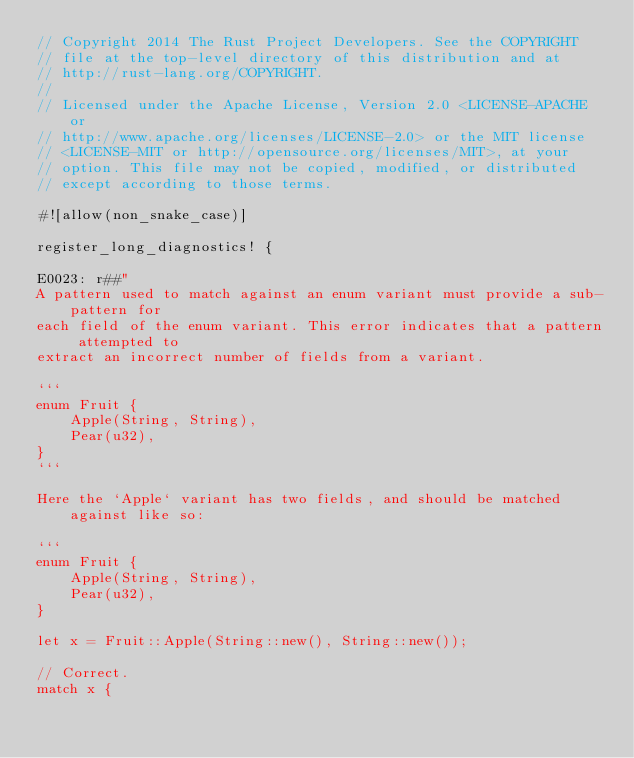Convert code to text. <code><loc_0><loc_0><loc_500><loc_500><_Rust_>// Copyright 2014 The Rust Project Developers. See the COPYRIGHT
// file at the top-level directory of this distribution and at
// http://rust-lang.org/COPYRIGHT.
//
// Licensed under the Apache License, Version 2.0 <LICENSE-APACHE or
// http://www.apache.org/licenses/LICENSE-2.0> or the MIT license
// <LICENSE-MIT or http://opensource.org/licenses/MIT>, at your
// option. This file may not be copied, modified, or distributed
// except according to those terms.

#![allow(non_snake_case)]

register_long_diagnostics! {

E0023: r##"
A pattern used to match against an enum variant must provide a sub-pattern for
each field of the enum variant. This error indicates that a pattern attempted to
extract an incorrect number of fields from a variant.

```
enum Fruit {
    Apple(String, String),
    Pear(u32),
}
```

Here the `Apple` variant has two fields, and should be matched against like so:

```
enum Fruit {
    Apple(String, String),
    Pear(u32),
}

let x = Fruit::Apple(String::new(), String::new());

// Correct.
match x {</code> 